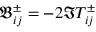<formula> <loc_0><loc_0><loc_500><loc_500>\mathfrak { B } _ { i j } ^ { \pm } = - 2 \Im T _ { i j } ^ { \pm }</formula> 